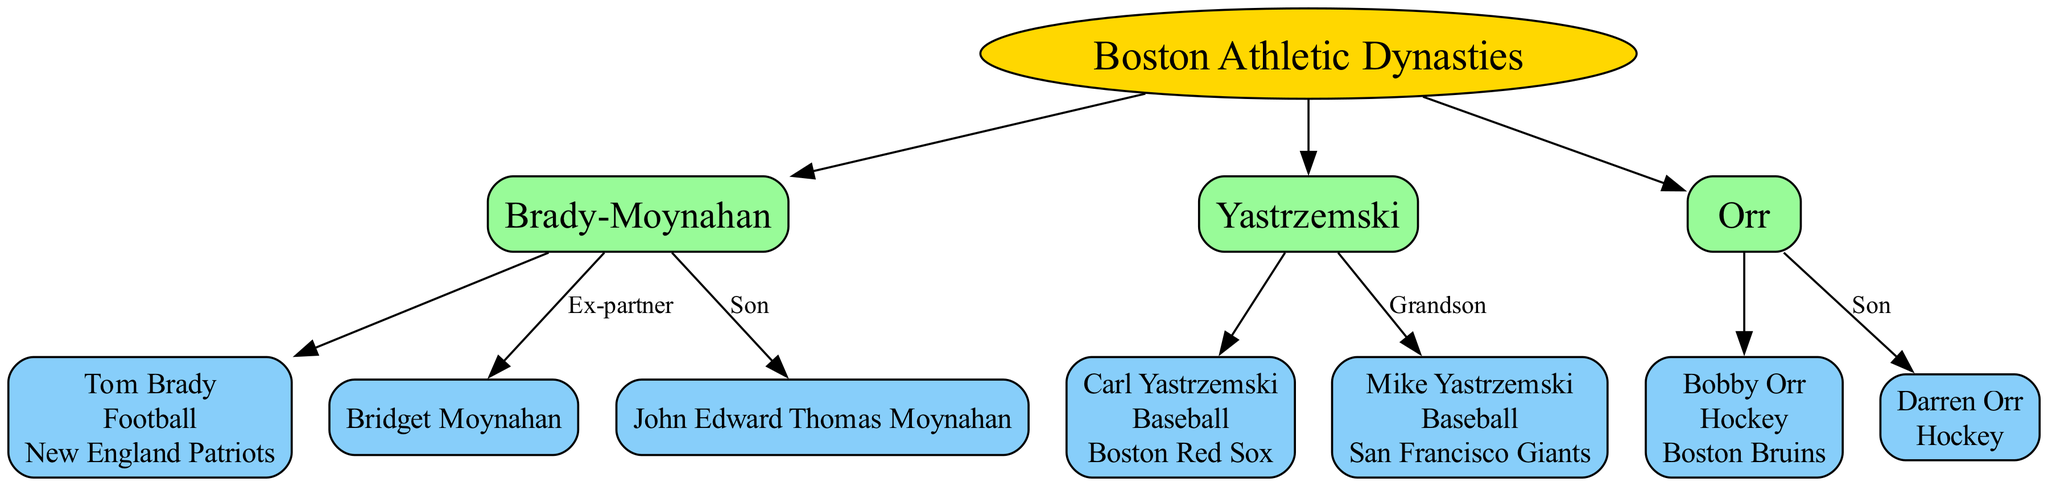What is the name of the root node? The root node is the topmost element in the diagram, which represents the overarching theme of the family lineage. By examining the diagram, I can see that the root node is labeled "Boston Athletic Dynasties."
Answer: Boston Athletic Dynasties How many families are listed in the diagram? To determine the number of families, I count the separate family groups connected to the root node. There are three distinct family nodes: Brady-Moynahan, Yastrzemski, and Orr.
Answer: 3 Who is the son of Tom Brady? The son's relationship is indicated in the diagram. Specifically, Tom Brady's son is mentioned under the Brady-Moynahan family, resulting in the identification of "John Edward Thomas Moynahan" as his son.
Answer: John Edward Thomas Moynahan Which sport does Carl Yastrzemski play? In the diagram, specific details about Carl Yastrzemski are listed alongside his name, particularly focusing on his sport and team. The diagram indicates that he plays Baseball.
Answer: Baseball Who is the grandson of Carl Yastrzemski? The diagram presents all family relationships and specifies that Mike Yastrzemski has the relationship labeled "Grandson" under the Yastrzemski family. This indicates that he is the grandson of Carl Yastrzemski.
Answer: Mike Yastrzemski What is the relation of Darren Orr to Bobby Orr? The diagram clearly indicates relationships with labels. Looking at the Orr family node, it states that Darren Orr is the "Son" of Bobby Orr, which defines their direct familial link.
Answer: Son Which team did Bobby Orr play for? The team affiliation for each athlete is listed next to their respective sport in the members' descriptions. Bobby Orr's details indicate that he played for the Boston Bruins.
Answer: Boston Bruins How many sports are represented in the diagram? To find the number of sports represented, I review the sports indicated next to each family member. The diagram shows Football, Baseball, and Hockey, leading to the conclusion that three different sports are represented.
Answer: 3 What is the relationship between Mike Yastrzemski and Carl Yastrzemski? The diagram employs labels to denote familial relationships. It indicates that Mike Yastrzemski's relationship to Carl Yastrzemski is that of "Grandson," further portraying their family connection.
Answer: Grandson 